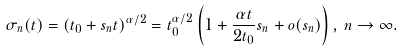<formula> <loc_0><loc_0><loc_500><loc_500>\sigma _ { n } ( t ) = ( t _ { 0 } + s _ { n } t ) ^ { \alpha / 2 } = t _ { 0 } ^ { \alpha / 2 } \left ( 1 + \frac { \alpha t } { 2 t _ { 0 } } s _ { n } + o ( s _ { n } ) \right ) , \, n \to \infty .</formula> 